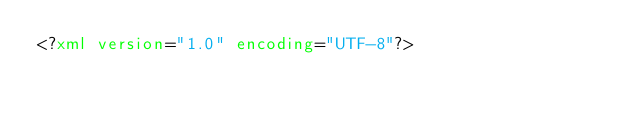Convert code to text. <code><loc_0><loc_0><loc_500><loc_500><_XML_><?xml version="1.0" encoding="UTF-8"?></code> 